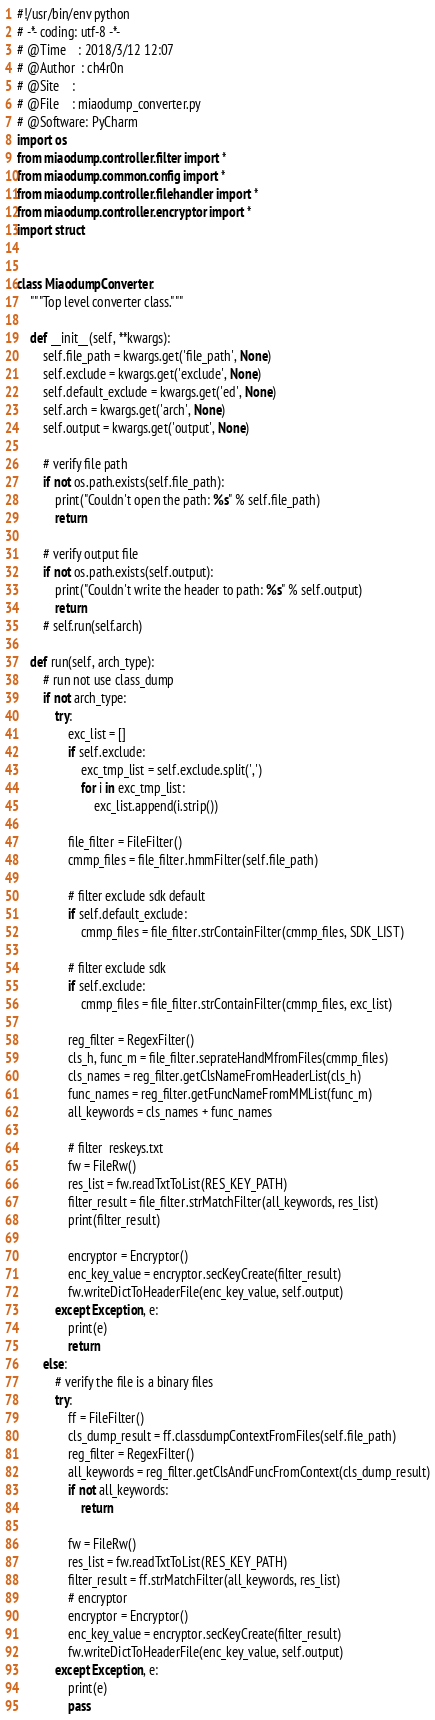Convert code to text. <code><loc_0><loc_0><loc_500><loc_500><_Python_>#!/usr/bin/env python
# -*- coding: utf-8 -*-
# @Time    : 2018/3/12 12:07
# @Author  : ch4r0n
# @Site    : 
# @File    : miaodump_converter.py
# @Software: PyCharm
import os
from miaodump.controller.filter import *
from miaodump.common.config import *
from miaodump.controller.filehandler import *
from miaodump.controller.encryptor import *
import struct


class MiaodumpConverter:
    """Top level converter class."""

    def __init__(self, **kwargs):
        self.file_path = kwargs.get('file_path', None)
        self.exclude = kwargs.get('exclude', None)
        self.default_exclude = kwargs.get('ed', None)
        self.arch = kwargs.get('arch', None)
        self.output = kwargs.get('output', None)

        # verify file path
        if not os.path.exists(self.file_path):
            print("Couldn't open the path: %s" % self.file_path)
            return

        # verify output file
        if not os.path.exists(self.output):
            print("Couldn't write the header to path: %s" % self.output)
            return
        # self.run(self.arch)

    def run(self, arch_type):
        # run not use class_dump
        if not arch_type:
            try:
                exc_list = []
                if self.exclude:
                    exc_tmp_list = self.exclude.split(',')
                    for i in exc_tmp_list:
                        exc_list.append(i.strip())

                file_filter = FileFilter()
                cmmp_files = file_filter.hmmFilter(self.file_path)

                # filter exclude sdk default
                if self.default_exclude:
                    cmmp_files = file_filter.strContainFilter(cmmp_files, SDK_LIST)

                # filter exclude sdk
                if self.exclude:
                    cmmp_files = file_filter.strContainFilter(cmmp_files, exc_list)

                reg_filter = RegexFilter()
                cls_h, func_m = file_filter.seprateHandMfromFiles(cmmp_files)
                cls_names = reg_filter.getClsNameFromHeaderList(cls_h)
                func_names = reg_filter.getFuncNameFromMMList(func_m)
                all_keywords = cls_names + func_names

                # filter  reskeys.txt
                fw = FileRw()
                res_list = fw.readTxtToList(RES_KEY_PATH)
                filter_result = file_filter.strMatchFilter(all_keywords, res_list)
                print(filter_result)

                encryptor = Encryptor()
                enc_key_value = encryptor.secKeyCreate(filter_result)
                fw.writeDictToHeaderFile(enc_key_value, self.output)
            except Exception, e:
                print(e)
                return
        else:
            # verify the file is a binary files
            try:
                ff = FileFilter()
                cls_dump_result = ff.classdumpContextFromFiles(self.file_path)
                reg_filter = RegexFilter()
                all_keywords = reg_filter.getClsAndFuncFromContext(cls_dump_result)
                if not all_keywords:
                    return
                
                fw = FileRw()
                res_list = fw.readTxtToList(RES_KEY_PATH)
                filter_result = ff.strMatchFilter(all_keywords, res_list)
                # encryptor
                encryptor = Encryptor()
                enc_key_value = encryptor.secKeyCreate(filter_result)
                fw.writeDictToHeaderFile(enc_key_value, self.output)
            except Exception, e:
                print(e)
                pass
</code> 